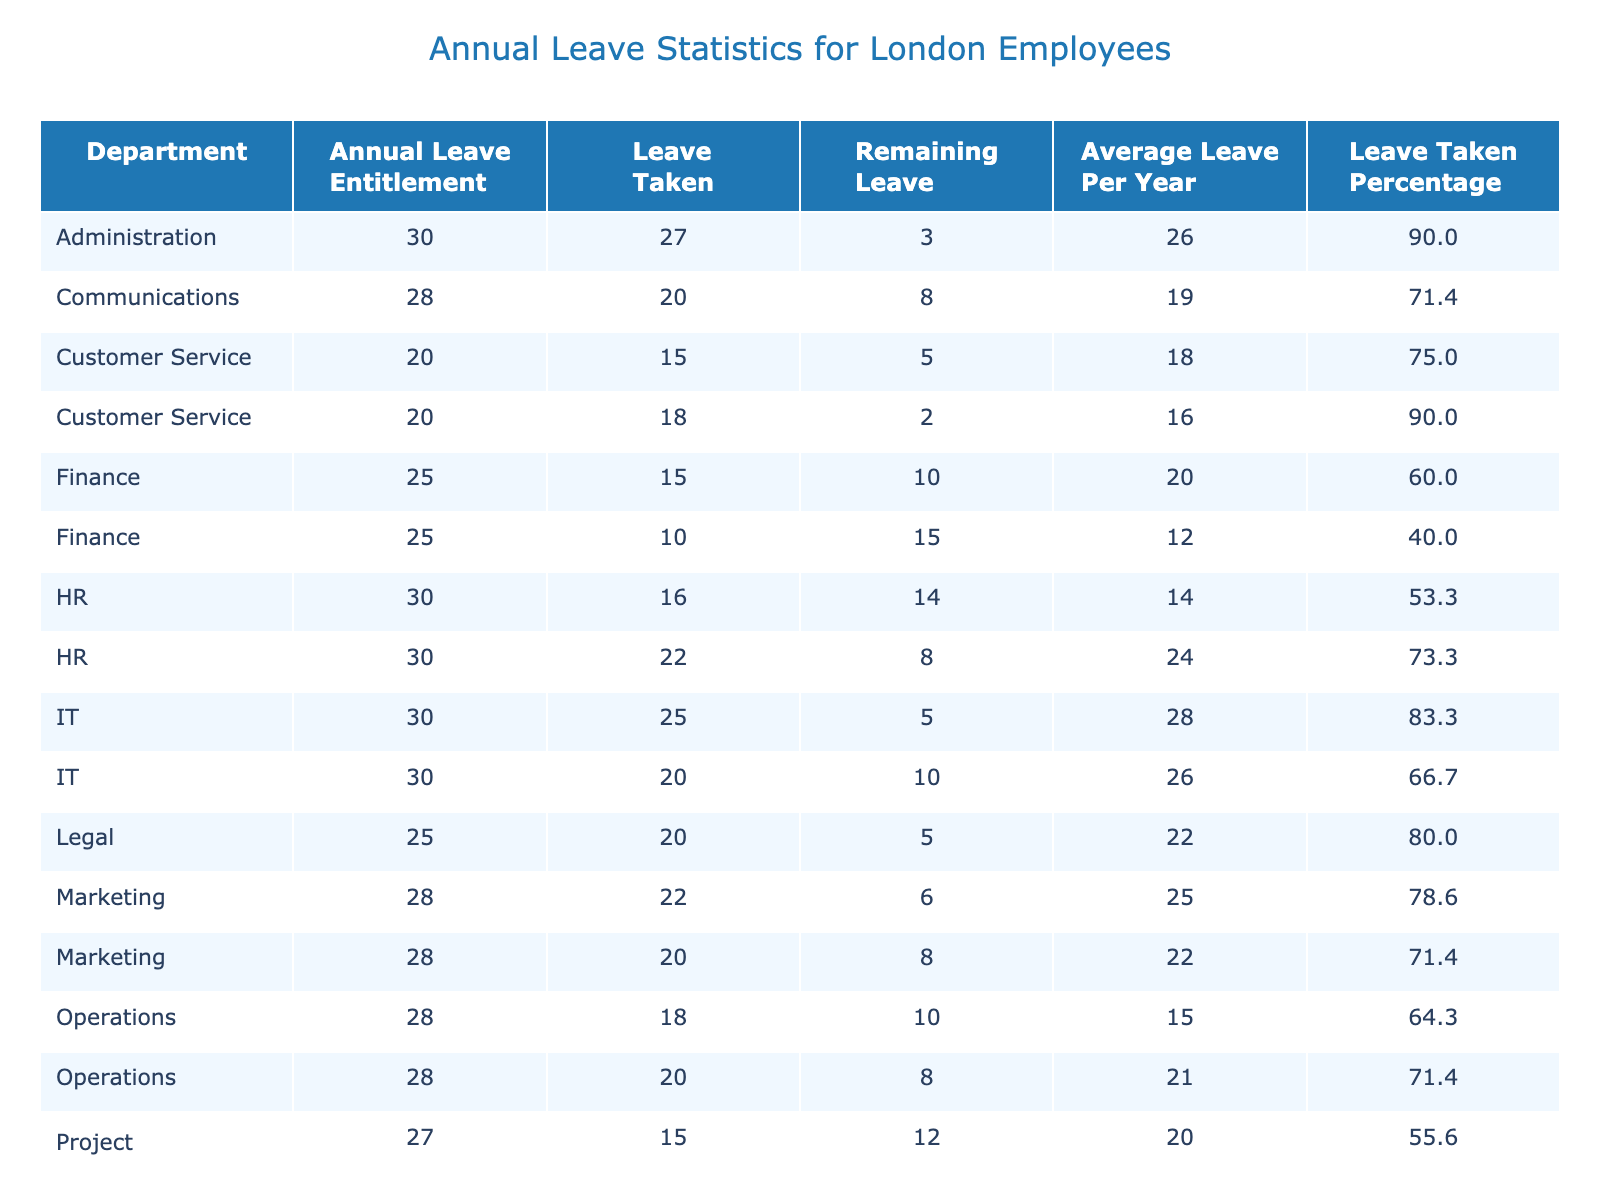What is the annual leave entitlement for the IT department? The table shows that the IT department has an annual leave entitlement of 30 days.
Answer: 30 Which department took the most leave in 2022? By comparing the Leave Taken values for all departments in 2022, the Administration department took the most leave at 27 days.
Answer: Administration What is the remaining leave for the HR department in 2023? According to the table, the remaining leave for the HR department in 2023 is 14 days.
Answer: 14 What is the average leave taken across all departments in 2022? To find the average leave taken, sum the Leave Taken values for 2022 (20 + 15 + 25 + 22 + 10 + 18 + 16 + 15 + 20 + 27 + 15 + 20) =  20.5. Divide by the number of departments, which is 12: 243 / 12 = 20.25.
Answer: 20.25 Is the leave taken in 2023 higher than in 2022 for the R&D department? In 2022, the R&D department took 16 days of leave, while in 2023, they took 10 days. Therefore, the leave taken in 2023 is lower than in 2022.
Answer: No Which department has the highest percentage of leave taken in 2022? Calculate the Leave Taken Percentage for each department in 2022: Marketing 71.4%, Finance 60.0%, IT 83.3%, HR 73.3%, Sales 41.7%, Operations 64.3%, R&D 61.5%, Customer Service 75.0%, Legal 80.0%, Administration 90.0%, Project Management 55.6%, Communications 71.4%. The Administration department has the highest percentage at 90.0%.
Answer: Administration How many departments have remaining leave less than 10 days in 2023? From the data for 2023, count the departments with remaining leave: Finance 15, IT 10, Marketing 6, Sales 9, HR 14, Operations 8, R&D 16, and Customer Service 2. The Customer Service and Marketing departments have remaining leave less than 10 days. Therefore, there are 2 departments.
Answer: 2 What is the difference in annual leave entitlement between the Marketing department and Sales department? The Marketing department has an annual leave entitlement of 28 days, while the Sales department has 24 days. Therefore, the difference is 28 - 24 = 4 days.
Answer: 4 Did any department take all of their annual leave in 2022? Looking at the table, the Administration department took 27 days, which is just below the 30-day entitlement. No department took all of their leave entitlements.
Answer: No 